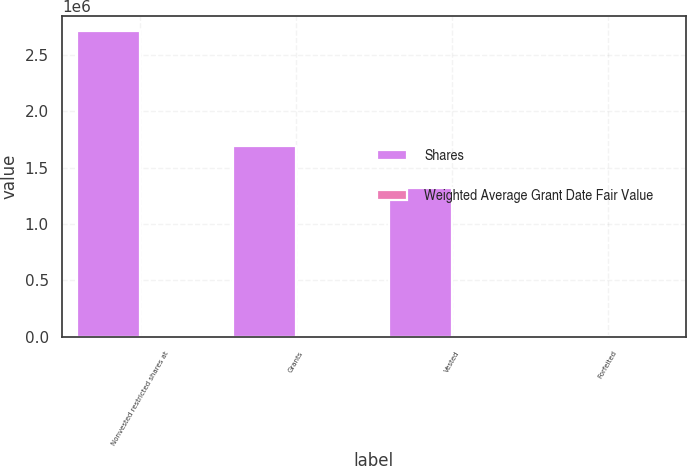<chart> <loc_0><loc_0><loc_500><loc_500><stacked_bar_chart><ecel><fcel>Nonvested restricted shares at<fcel>Grants<fcel>Vested<fcel>Forfeited<nl><fcel>Shares<fcel>2.7089e+06<fcel>1.68806e+06<fcel>1.3179e+06<fcel>10750<nl><fcel>Weighted Average Grant Date Fair Value<fcel>13.79<fcel>15.21<fcel>14.64<fcel>19.38<nl></chart> 